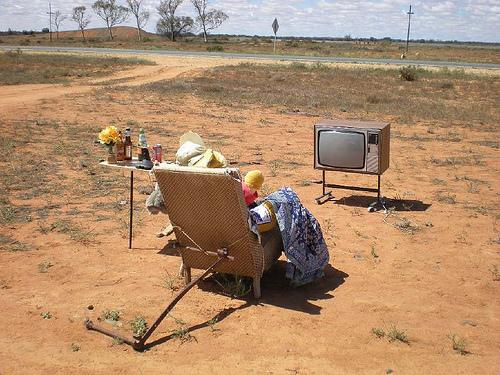Why can't they watch the television? no electricity 